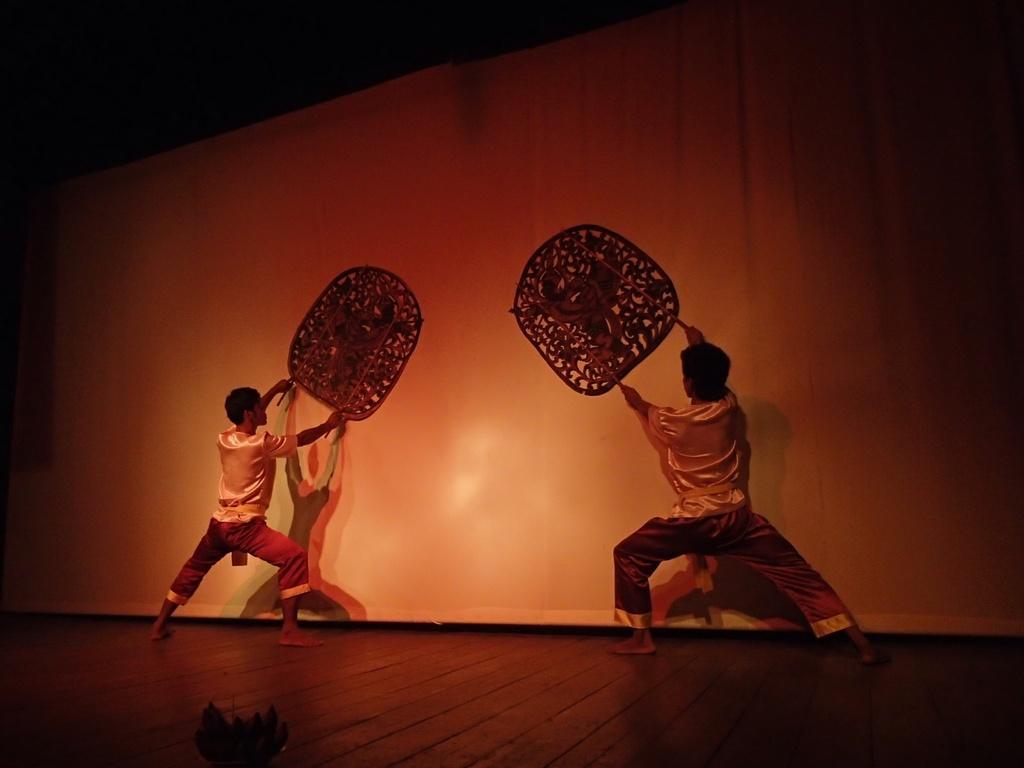Please provide a concise description of this image. There is an activity being performed by two boys on the stage. 